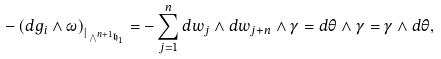Convert formula to latex. <formula><loc_0><loc_0><loc_500><loc_500>- \left ( d g _ { i } \wedge \omega \right ) _ { | _ { { { } \bigwedge } ^ { n + 1 } \mathfrak { h } _ { 1 } } } = - \sum _ { j = 1 } ^ { n } d w _ { j } \wedge d w _ { j + n } \wedge \gamma = d \theta \wedge \gamma = \gamma \wedge d \theta ,</formula> 